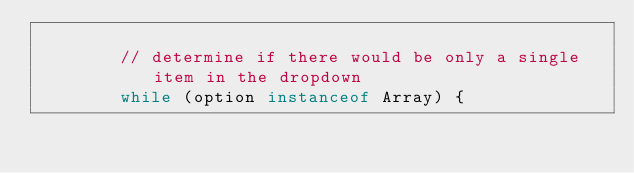<code> <loc_0><loc_0><loc_500><loc_500><_JavaScript_>
        // determine if there would be only a single item in the dropdown
        while (option instanceof Array) {</code> 